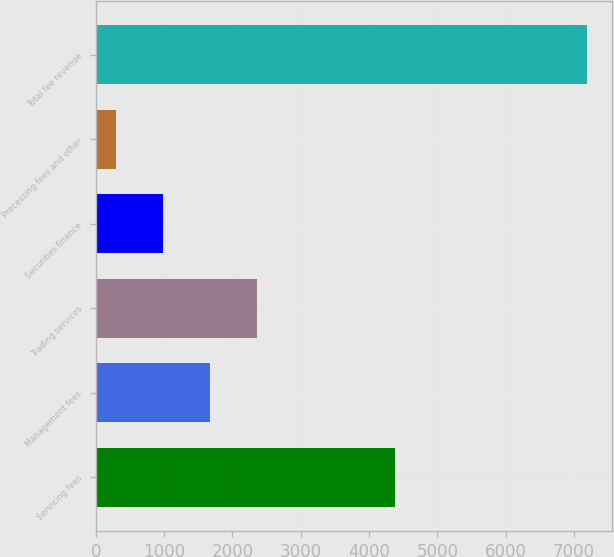<chart> <loc_0><loc_0><loc_500><loc_500><bar_chart><fcel>Servicing fees<fcel>Management fees<fcel>Trading services<fcel>Securities finance<fcel>Processing fees and other<fcel>Total fee revenue<nl><fcel>4382<fcel>1676.4<fcel>2366.1<fcel>986.7<fcel>297<fcel>7194<nl></chart> 